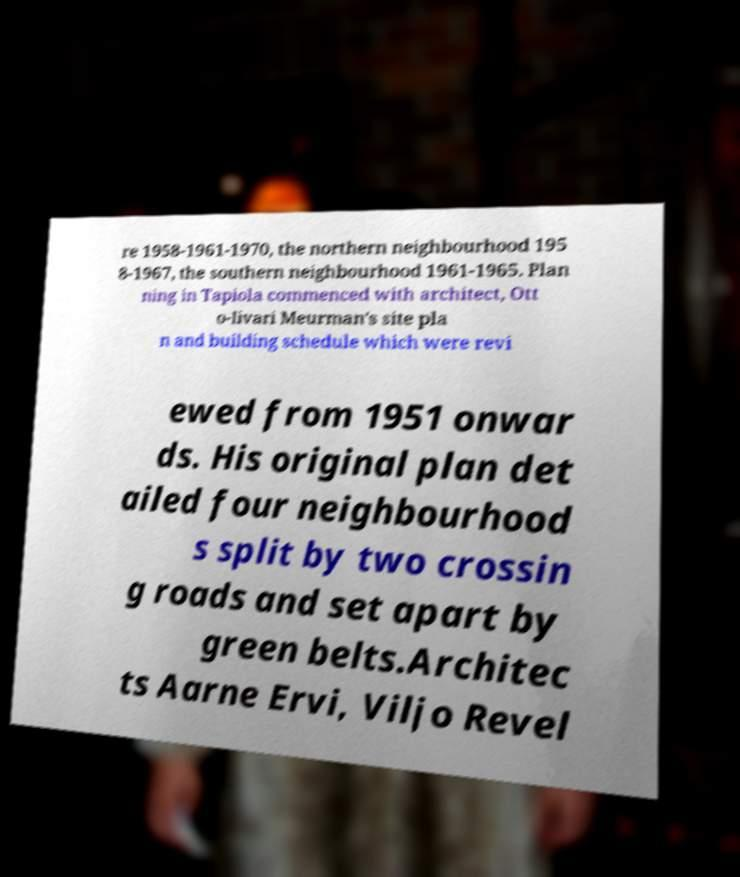Please identify and transcribe the text found in this image. re 1958-1961-1970, the northern neighbourhood 195 8-1967, the southern neighbourhood 1961-1965. Plan ning in Tapiola commenced with architect, Ott o-Iivari Meurman's site pla n and building schedule which were revi ewed from 1951 onwar ds. His original plan det ailed four neighbourhood s split by two crossin g roads and set apart by green belts.Architec ts Aarne Ervi, Viljo Revel 